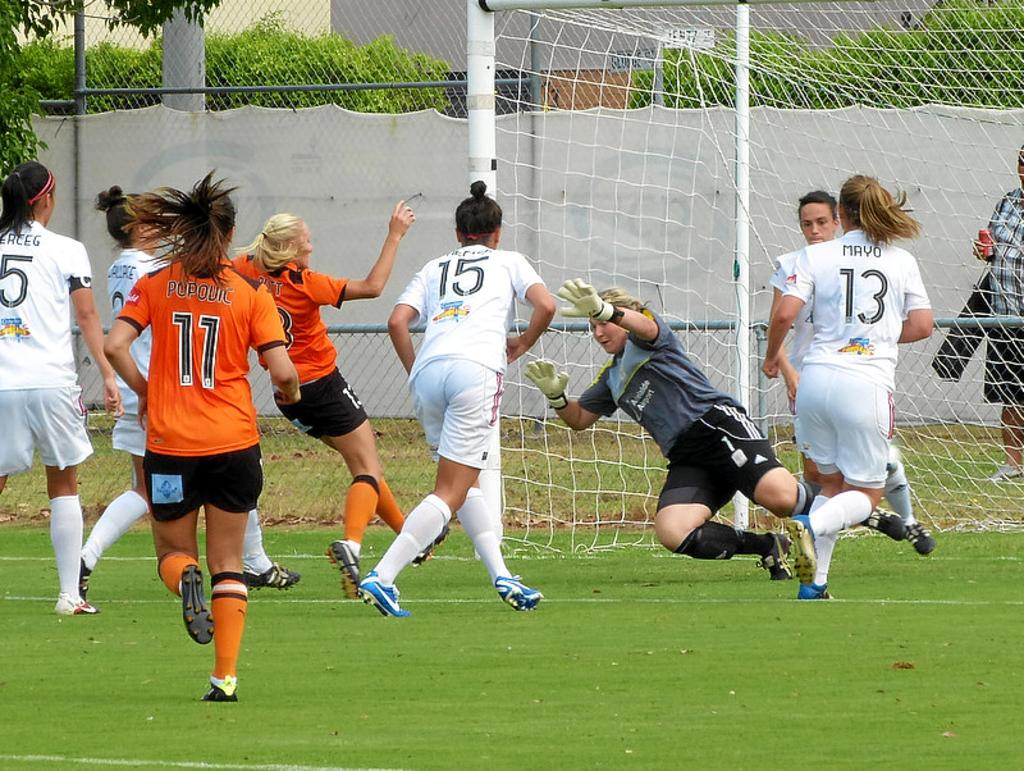What is happening in the image involving a group of women? The women are playing a game in the ground. What can be seen in the background of the image? Trees are present behind the mesh. What is the mesh used for in the image? The mesh is visible in the image, but its purpose is not specified. Can you see a receipt for the mint purchase in the image? There is no receipt or mint purchase present in the image. 